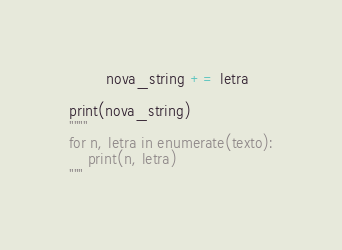Convert code to text. <code><loc_0><loc_0><loc_500><loc_500><_Python_>        nova_string += letra

print(nova_string)
""""
for n, letra in enumerate(texto):
    print(n, letra)
"""
</code> 